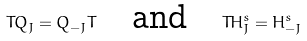Convert formula to latex. <formula><loc_0><loc_0><loc_500><loc_500>T Q _ { J } = Q _ { - J } T \quad \text {and} \quad T H ^ { s } _ { J } = H ^ { s } _ { - J }</formula> 